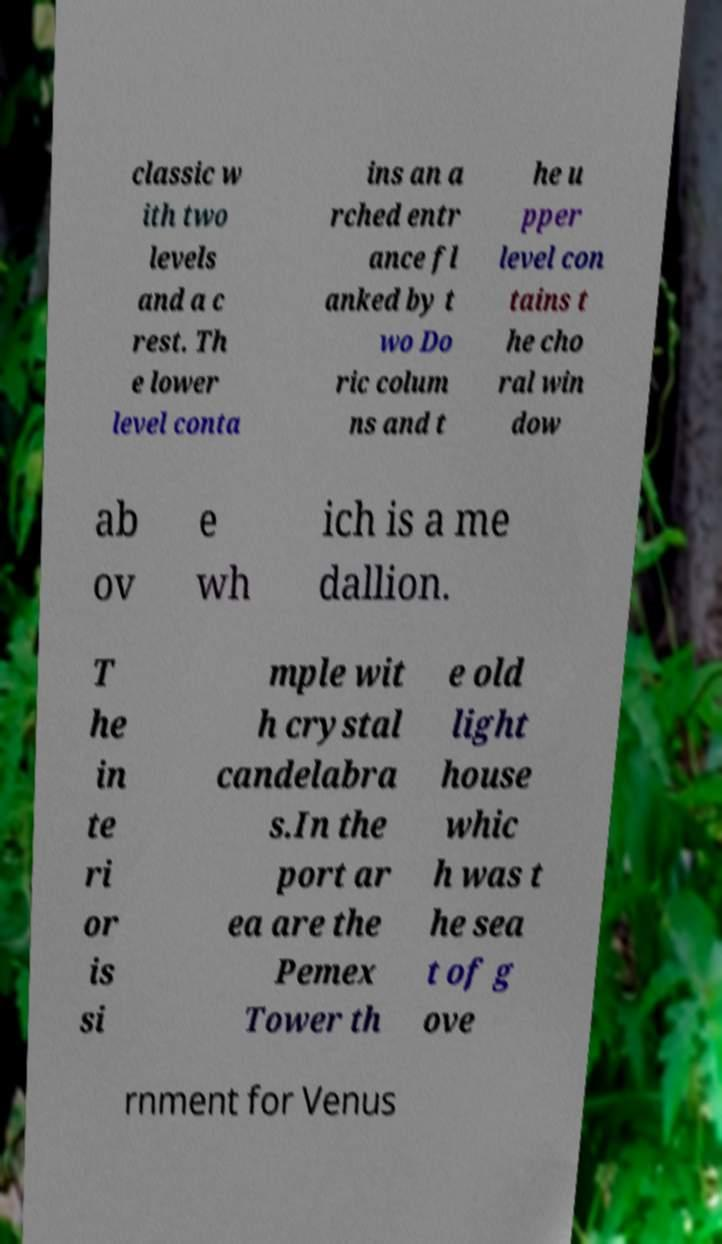Please identify and transcribe the text found in this image. classic w ith two levels and a c rest. Th e lower level conta ins an a rched entr ance fl anked by t wo Do ric colum ns and t he u pper level con tains t he cho ral win dow ab ov e wh ich is a me dallion. T he in te ri or is si mple wit h crystal candelabra s.In the port ar ea are the Pemex Tower th e old light house whic h was t he sea t of g ove rnment for Venus 